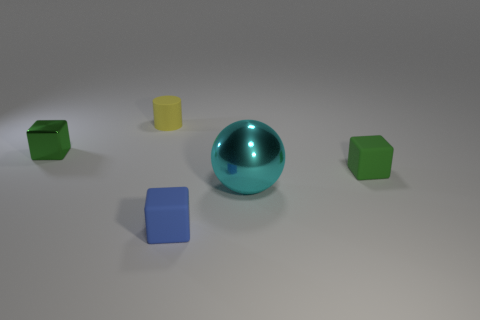There is a yellow object that is made of the same material as the tiny blue object; what size is it?
Your response must be concise. Small. There is a rubber block that is the same color as the small metal object; what size is it?
Offer a very short reply. Small. What number of other things are the same size as the metallic sphere?
Your answer should be very brief. 0. What material is the cube right of the big sphere?
Provide a short and direct response. Rubber. There is a metal thing that is in front of the green object that is to the right of the thing left of the yellow object; what shape is it?
Keep it short and to the point. Sphere. Does the green rubber thing have the same size as the blue thing?
Keep it short and to the point. Yes. How many things are tiny metal blocks or green blocks that are right of the big cyan metal sphere?
Offer a very short reply. 2. What number of things are objects behind the big cyan sphere or metal things in front of the green rubber cube?
Ensure brevity in your answer.  4. Are there any tiny blue rubber objects left of the tiny blue thing?
Make the answer very short. No. The block that is in front of the green thing that is right of the metal object left of the yellow rubber cylinder is what color?
Provide a short and direct response. Blue. 